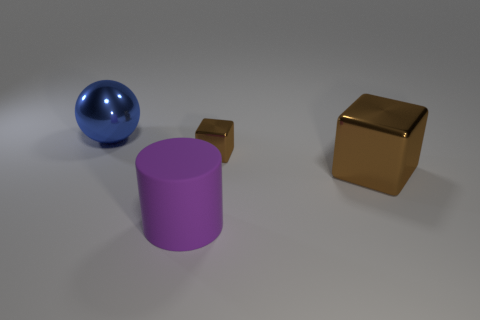Add 2 large purple cylinders. How many objects exist? 6 Subtract all cylinders. How many objects are left? 3 Subtract all small brown cubes. Subtract all cylinders. How many objects are left? 2 Add 1 brown things. How many brown things are left? 3 Add 4 large purple cylinders. How many large purple cylinders exist? 5 Subtract 0 brown cylinders. How many objects are left? 4 